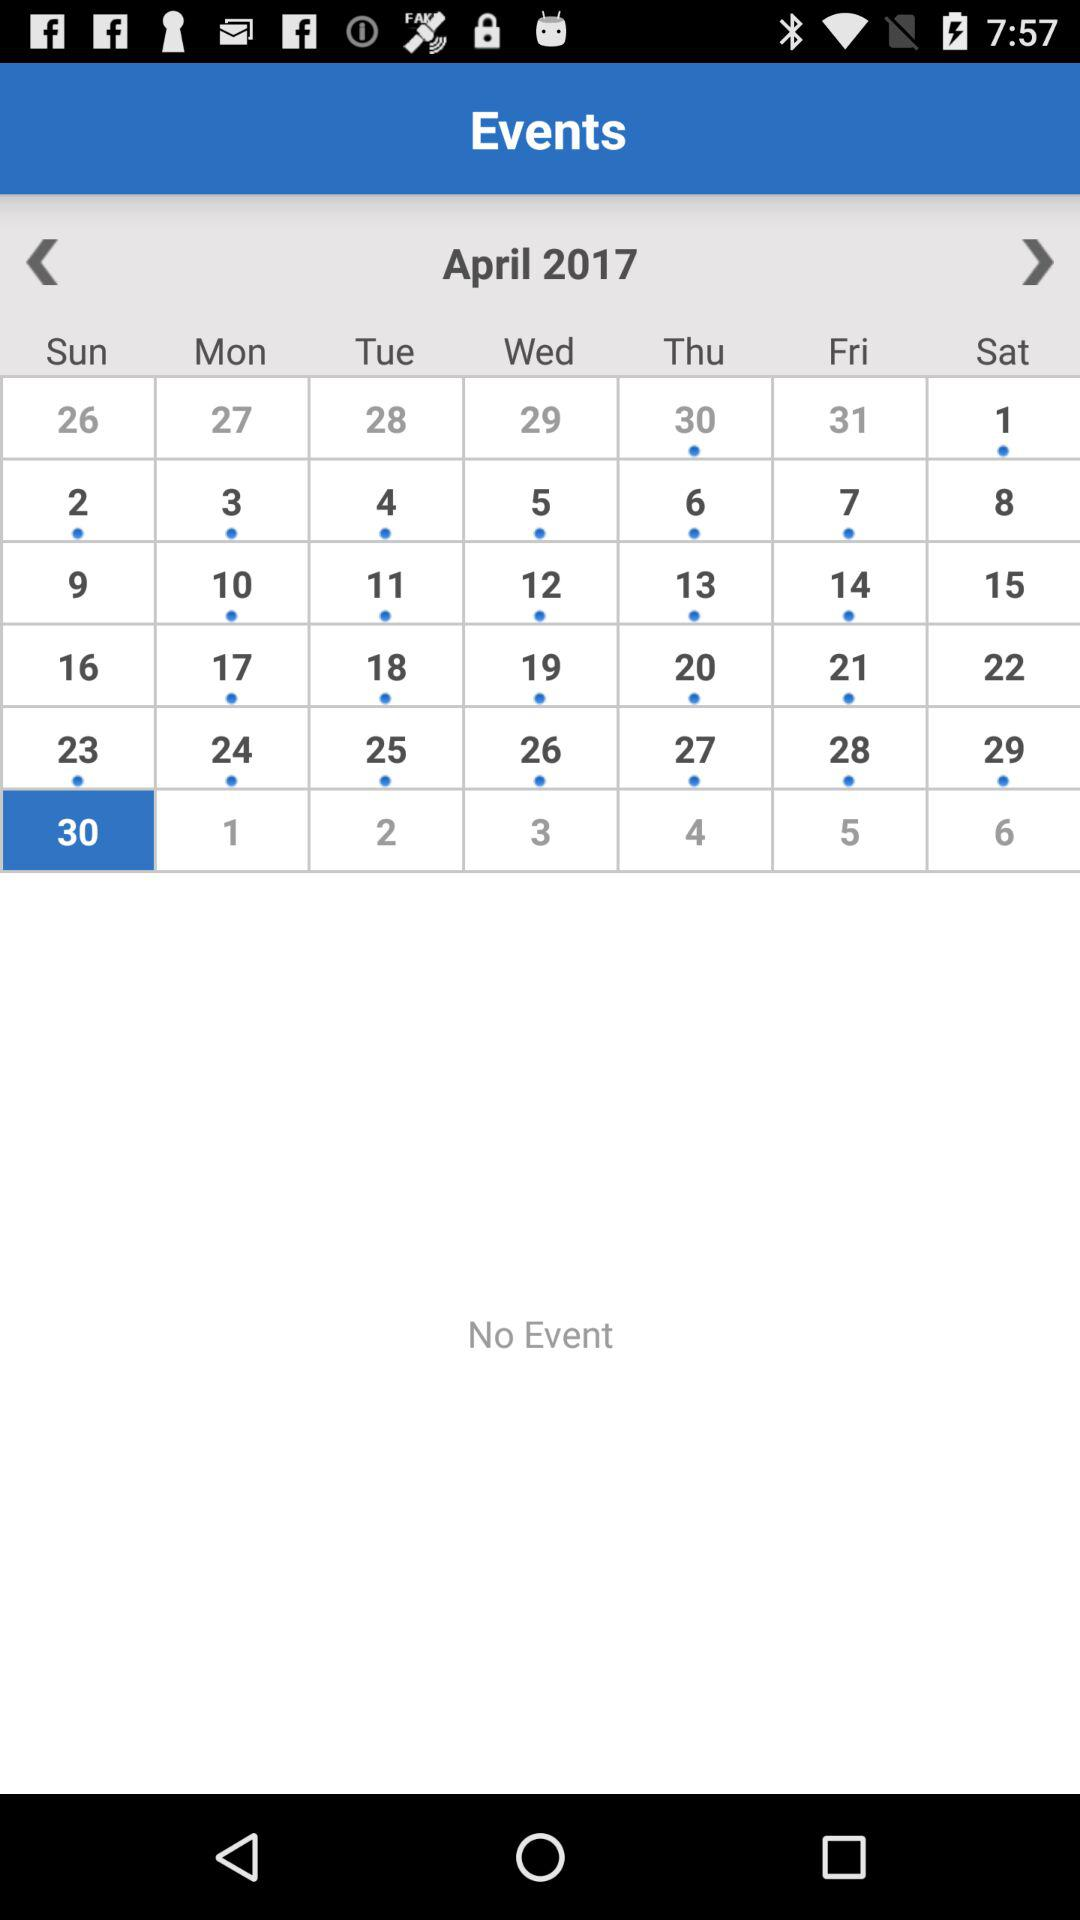Which holiday falls on Sunday, April 30, 2017?
When the provided information is insufficient, respond with <no answer>. <no answer> 